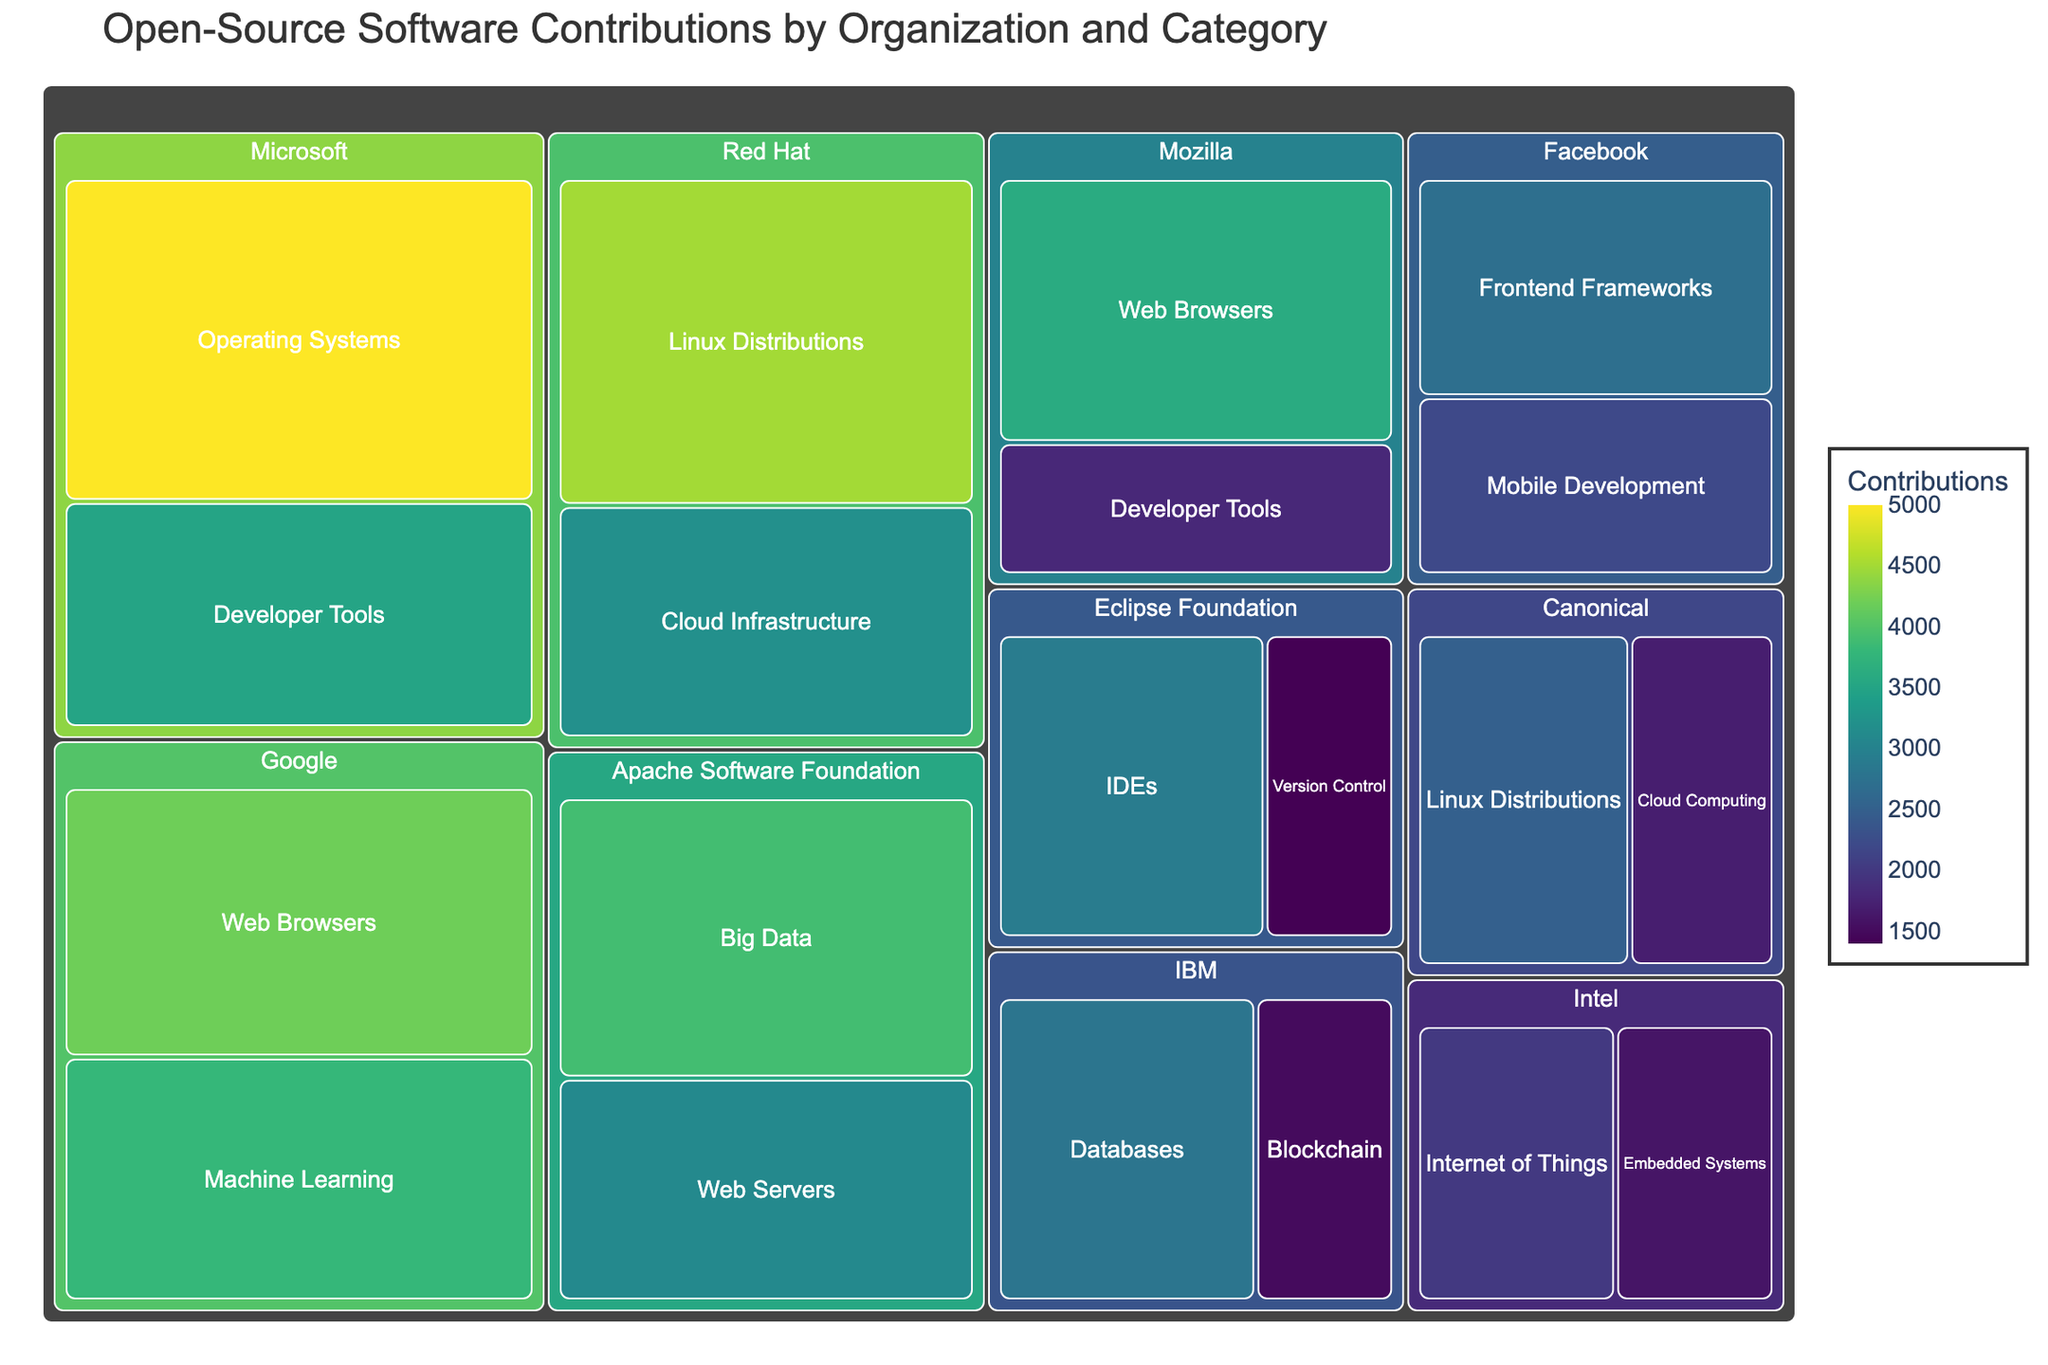What is the title of the treemap? The title of the treemap is usually displayed at the top of the plot. It provides context about what is being visualized.
Answer: Open-Source Software Contributions by Organization and Category Which organization has the highest number of contributions in the "Linux Distributions" category? To find this, look at the "Linux Distributions" group within the treemap and then identify the organization with the largest area (most contributions) in that section.
Answer: Red Hat What are the total contributions made by Facebook? Locate the sections corresponding to Facebook in the treemap and sum the contributions in both categories labeled with Facebook.
Answer: 4900 Which category has the most contributions from Google? Inspect the sections labeled under Google and compare the areas (or numerical values) for each category listed under Google.
Answer: Web Browsers Compare the operating systems contributions between Microsoft and Red Hat. Which organization contributed more? Locate the sections for "Operating Systems" under both Microsoft and Red Hat. Compare the numerical values to determine which is higher.
Answer: Microsoft contributed more What is the contribution difference between IBM and Canonical in total? Sum up the contributions from all categories for IBM and Canonical. Subtract the total contributions of Canonical from the total contributions of IBM to find the difference.
Answer: 1100 Are there more contributions in "Web Browsers" by Google or Mozilla? Inspect the "Web Browsers" sections under Google and Mozilla, then compare their contribution values.
Answer: Google Which organization has the smallest contribution in any category, and what is it? Scan through the treemap to identify the smallest area (lowest numerical value) across all categories and note the corresponding organization.
Answer: Eclipse Foundation in Version Control with 1400 contributions How many contributions have been made in the "Developer Tools" category overall? Locate all the contributions made under the "Developer Tools" category irrespective of the organization and sum them up.
Answer: 5300 